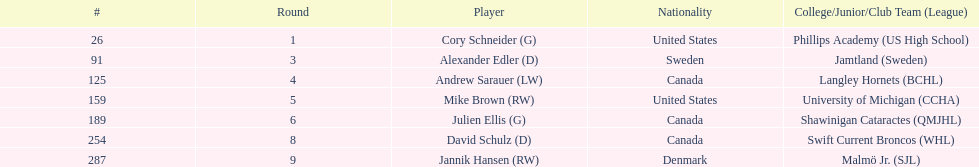List only the american players. Cory Schneider (G), Mike Brown (RW). 